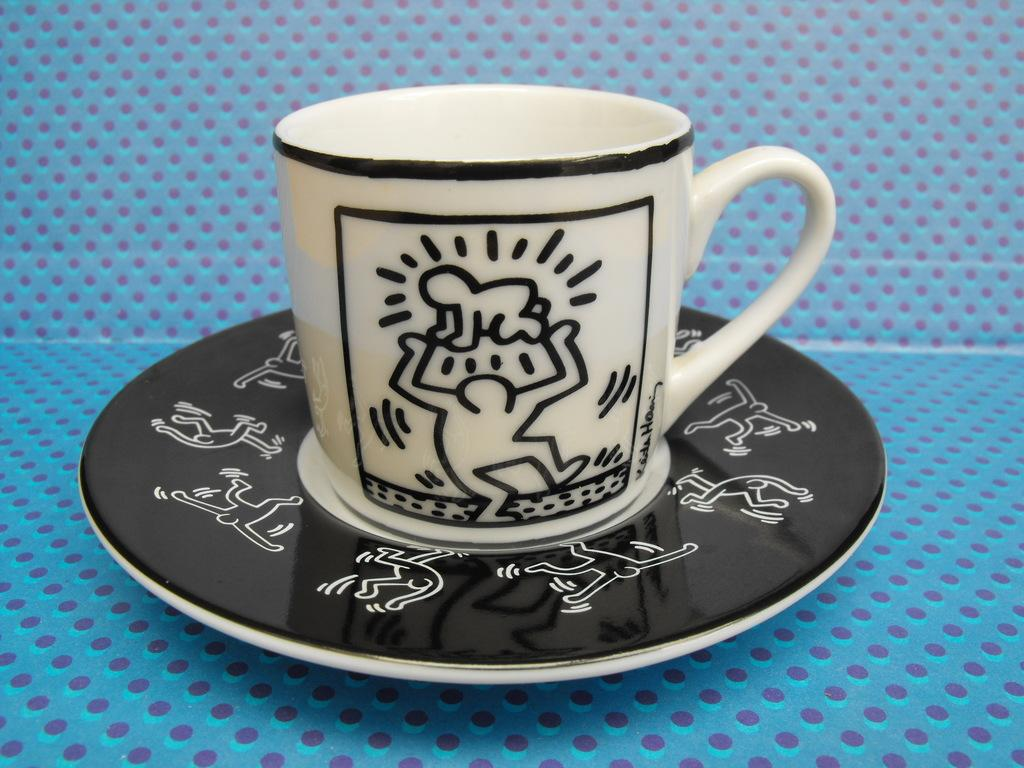What is the main object in the image? There is a cup in the image. Is the cup placed on any other object? Yes, the cup is in a saucer. Where is the cup and saucer located? The cup and saucer are placed on a surface. What type of treatment is being administered to the cup in the image? There is no treatment being administered to the cup in the image; it is simply sitting in the saucer on a surface. 